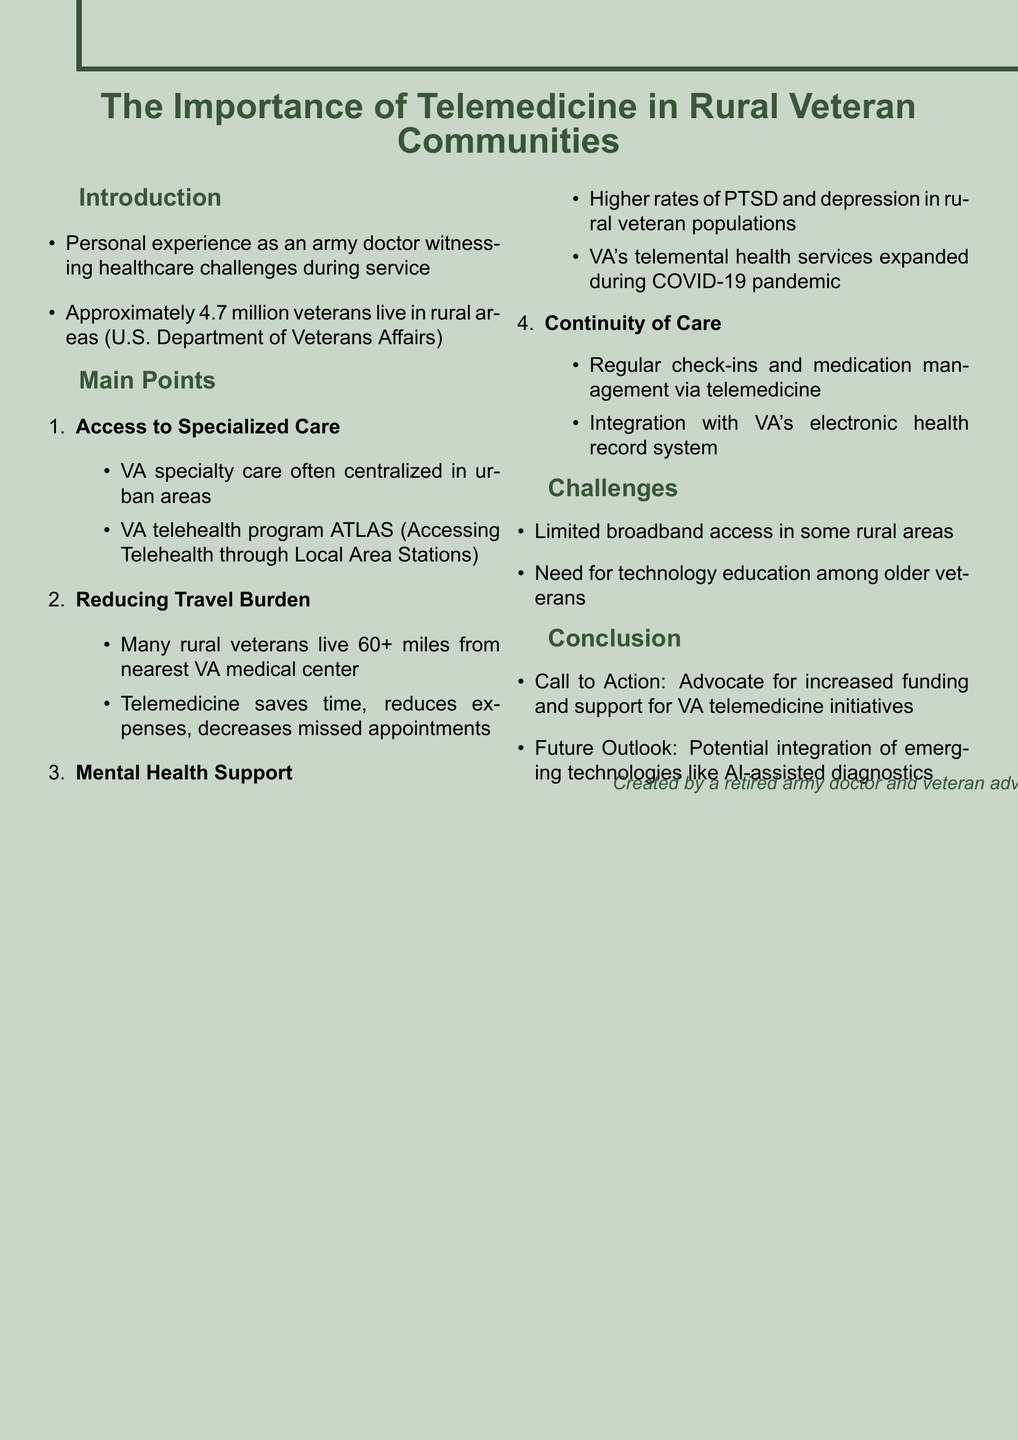What is the title of the presentation? The title is explicitly stated at the beginning of the document.
Answer: The Importance of Telemedicine in Rural Veteran Communities How many veterans live in rural areas according to the document? The document cites a statistic provided by the U.S. Department of Veterans Affairs regarding rural veterans.
Answer: Approximately 4.7 million What is one program mentioned that relates to telehealth? The document lists a specific telehealth program as an example of access to specialized care.
Answer: ATLAS What common distance do many rural veterans live from the nearest VA medical center? The document indicates a specific distance that illustrates the travel burden faced by rural veterans.
Answer: 60+ miles Which demographic has higher rates of PTSD and depression according to the presentation? The document addresses a specific population that experiences higher rates of these mental health issues.
Answer: Rural veteran populations What is one challenge listed in the presentation regarding telemedicine? The document includes challenges faced in rural areas that impact the delivery of telemedicine services.
Answer: Limited broadband access What is the call to action in the conclusion? The document concludes with a specific advocacy request regarding telemedicine initiatives.
Answer: Advocate for increased funding What future outlook does the document suggest for telemedicine? The document provides an insight into potential developments that may enhance telemedicine services.
Answer: AI-assisted diagnostics 